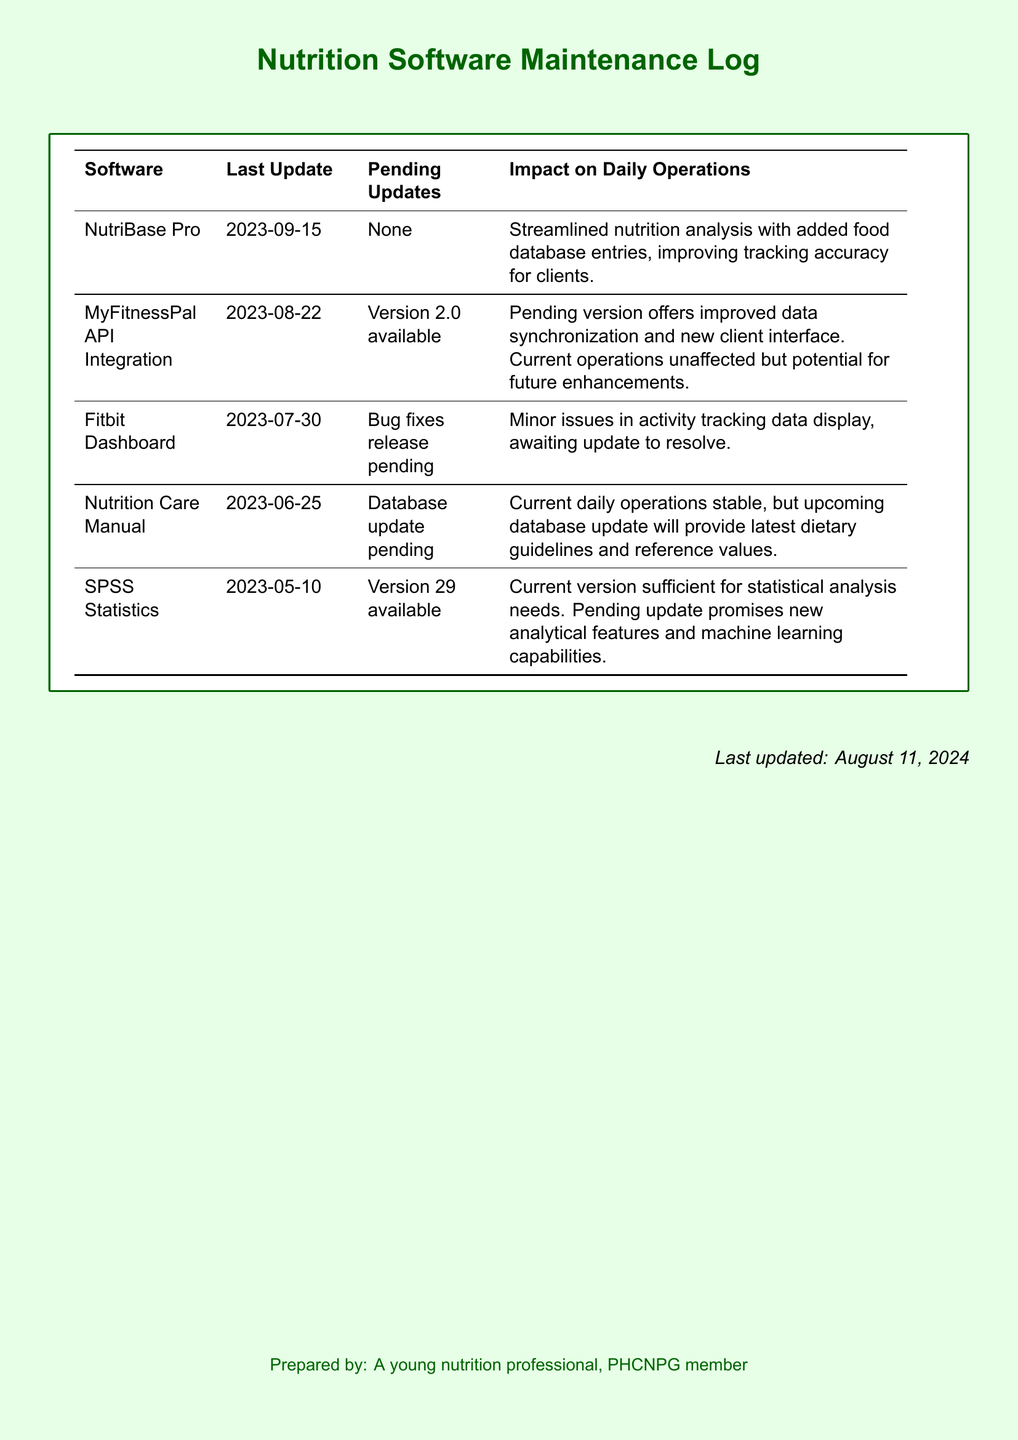What is the last update date for NutriBase Pro? The last update date for NutriBase Pro is explicitly stated in the document under the "Last Update" column.
Answer: 2023-09-15 What pending updates are there for MyFitnessPal API Integration? The document specifies the pending updates in the "Pending Updates" column, which indicates that a new version is available.
Answer: Version 2.0 available What impact do the pending updates for the Fitbit Dashboard have on daily operations? The "Impact on Daily Operations" section for Fitbit Dashboard mentions that there are minor issues currently.
Answer: Minor issues in activity tracking data display When was the last update for SPSS Statistics? The document lists the last update date for SPSS Statistics, found in the relevant column.
Answer: 2023-05-10 What update is pending for the Nutrition Care Manual? The document provides information on pending updates for each software, including the Nutrition Care Manual.
Answer: Database update pending Which software had its last update before July 2023? The reasoning requires analyzing the "Last Update" dates for all software listed.
Answer: SPSS Statistics Which software has no pending updates listed? The "Pending Updates" column is checked for entries that indicate none are present.
Answer: NutriBase Pro What is the major feature included in the pending update for SPSS Statistics? The pending update details in the document include new features.
Answer: New analytical features and machine learning capabilities 